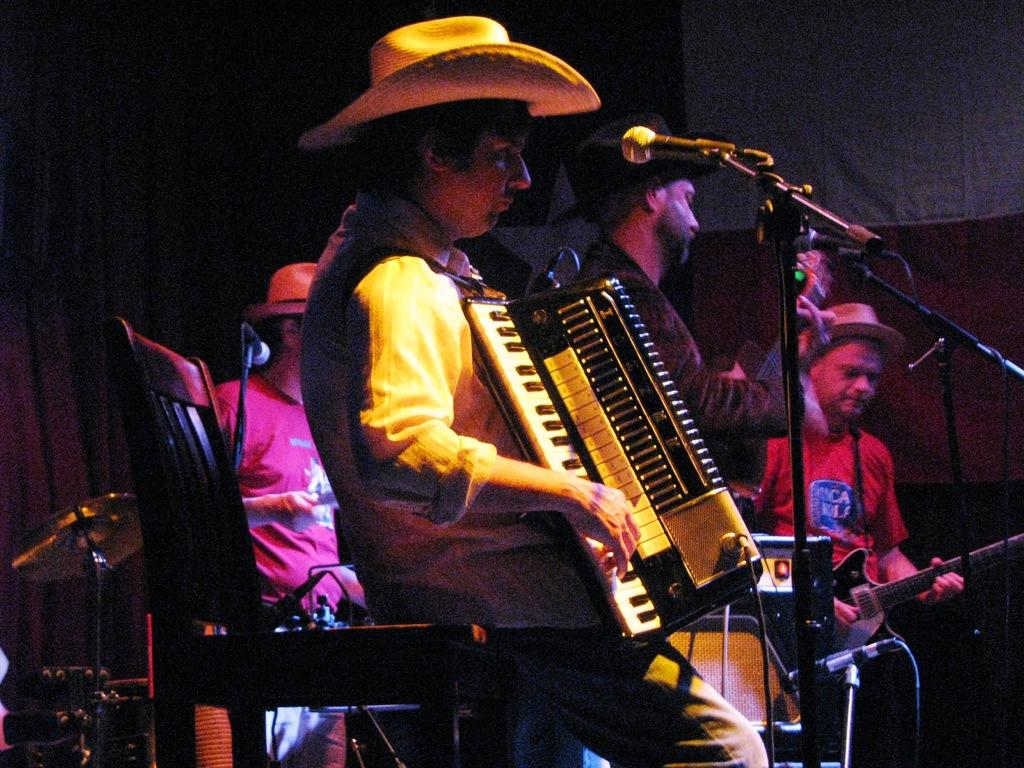What is happening in the image? There are people in the image, and they are playing musical instruments. Can you describe the people in the image? The people in the image are playing musical instruments, but their specific appearance cannot be determined from the provided facts. How many dimes are visible on the floor in the image? There is no mention of dimes in the provided facts, so it cannot be determined if any are visible in the image. 